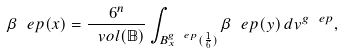Convert formula to latex. <formula><loc_0><loc_0><loc_500><loc_500>\beta _ { \ } e p ( x ) = \frac { 6 ^ { n } } { \ v o l ( \mathbb { B } ) } \int _ { B ^ { g _ { \ } e p } _ { x } ( \frac { 1 } { 6 } ) } \beta _ { \ } e p ( y ) \, d v ^ { g _ { \ } e p } ,</formula> 